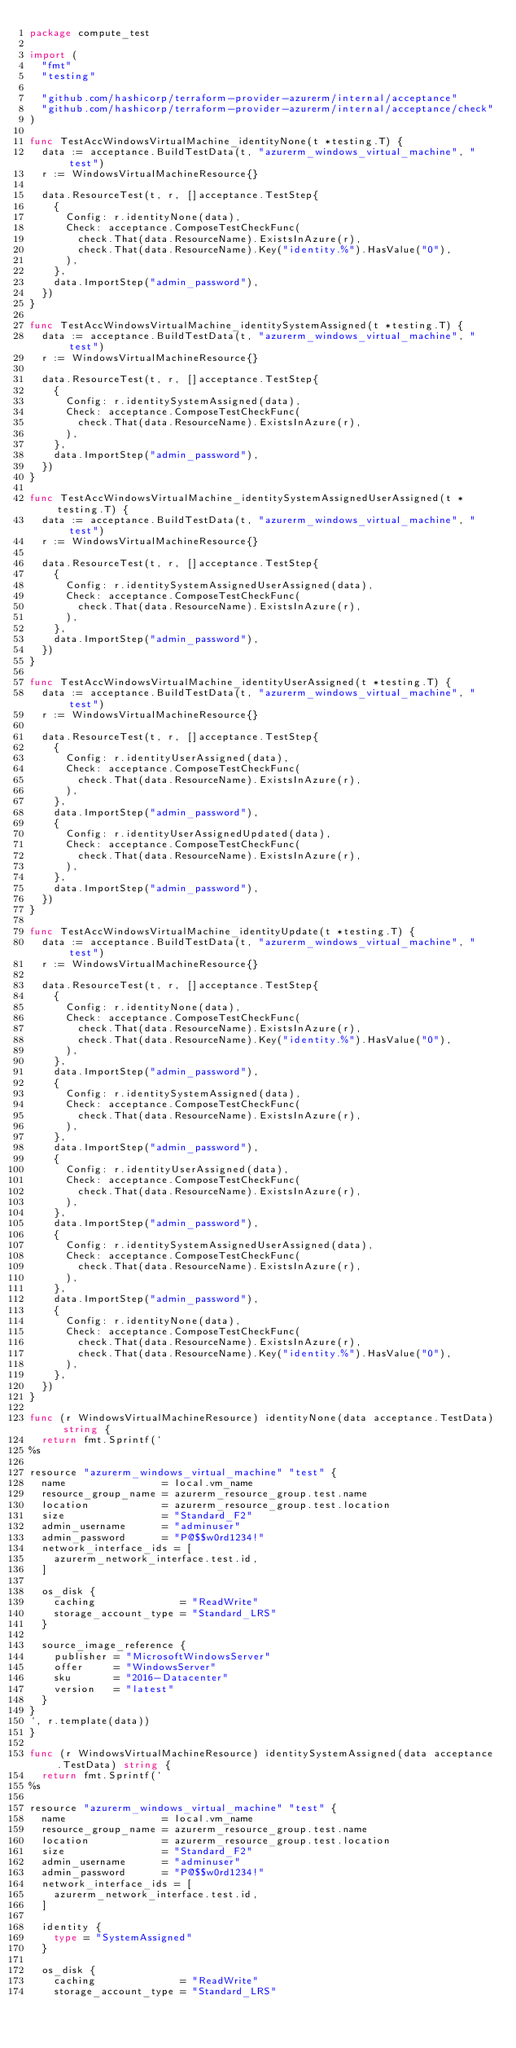Convert code to text. <code><loc_0><loc_0><loc_500><loc_500><_Go_>package compute_test

import (
	"fmt"
	"testing"

	"github.com/hashicorp/terraform-provider-azurerm/internal/acceptance"
	"github.com/hashicorp/terraform-provider-azurerm/internal/acceptance/check"
)

func TestAccWindowsVirtualMachine_identityNone(t *testing.T) {
	data := acceptance.BuildTestData(t, "azurerm_windows_virtual_machine", "test")
	r := WindowsVirtualMachineResource{}

	data.ResourceTest(t, r, []acceptance.TestStep{
		{
			Config: r.identityNone(data),
			Check: acceptance.ComposeTestCheckFunc(
				check.That(data.ResourceName).ExistsInAzure(r),
				check.That(data.ResourceName).Key("identity.%").HasValue("0"),
			),
		},
		data.ImportStep("admin_password"),
	})
}

func TestAccWindowsVirtualMachine_identitySystemAssigned(t *testing.T) {
	data := acceptance.BuildTestData(t, "azurerm_windows_virtual_machine", "test")
	r := WindowsVirtualMachineResource{}

	data.ResourceTest(t, r, []acceptance.TestStep{
		{
			Config: r.identitySystemAssigned(data),
			Check: acceptance.ComposeTestCheckFunc(
				check.That(data.ResourceName).ExistsInAzure(r),
			),
		},
		data.ImportStep("admin_password"),
	})
}

func TestAccWindowsVirtualMachine_identitySystemAssignedUserAssigned(t *testing.T) {
	data := acceptance.BuildTestData(t, "azurerm_windows_virtual_machine", "test")
	r := WindowsVirtualMachineResource{}

	data.ResourceTest(t, r, []acceptance.TestStep{
		{
			Config: r.identitySystemAssignedUserAssigned(data),
			Check: acceptance.ComposeTestCheckFunc(
				check.That(data.ResourceName).ExistsInAzure(r),
			),
		},
		data.ImportStep("admin_password"),
	})
}

func TestAccWindowsVirtualMachine_identityUserAssigned(t *testing.T) {
	data := acceptance.BuildTestData(t, "azurerm_windows_virtual_machine", "test")
	r := WindowsVirtualMachineResource{}

	data.ResourceTest(t, r, []acceptance.TestStep{
		{
			Config: r.identityUserAssigned(data),
			Check: acceptance.ComposeTestCheckFunc(
				check.That(data.ResourceName).ExistsInAzure(r),
			),
		},
		data.ImportStep("admin_password"),
		{
			Config: r.identityUserAssignedUpdated(data),
			Check: acceptance.ComposeTestCheckFunc(
				check.That(data.ResourceName).ExistsInAzure(r),
			),
		},
		data.ImportStep("admin_password"),
	})
}

func TestAccWindowsVirtualMachine_identityUpdate(t *testing.T) {
	data := acceptance.BuildTestData(t, "azurerm_windows_virtual_machine", "test")
	r := WindowsVirtualMachineResource{}

	data.ResourceTest(t, r, []acceptance.TestStep{
		{
			Config: r.identityNone(data),
			Check: acceptance.ComposeTestCheckFunc(
				check.That(data.ResourceName).ExistsInAzure(r),
				check.That(data.ResourceName).Key("identity.%").HasValue("0"),
			),
		},
		data.ImportStep("admin_password"),
		{
			Config: r.identitySystemAssigned(data),
			Check: acceptance.ComposeTestCheckFunc(
				check.That(data.ResourceName).ExistsInAzure(r),
			),
		},
		data.ImportStep("admin_password"),
		{
			Config: r.identityUserAssigned(data),
			Check: acceptance.ComposeTestCheckFunc(
				check.That(data.ResourceName).ExistsInAzure(r),
			),
		},
		data.ImportStep("admin_password"),
		{
			Config: r.identitySystemAssignedUserAssigned(data),
			Check: acceptance.ComposeTestCheckFunc(
				check.That(data.ResourceName).ExistsInAzure(r),
			),
		},
		data.ImportStep("admin_password"),
		{
			Config: r.identityNone(data),
			Check: acceptance.ComposeTestCheckFunc(
				check.That(data.ResourceName).ExistsInAzure(r),
				check.That(data.ResourceName).Key("identity.%").HasValue("0"),
			),
		},
	})
}

func (r WindowsVirtualMachineResource) identityNone(data acceptance.TestData) string {
	return fmt.Sprintf(`
%s

resource "azurerm_windows_virtual_machine" "test" {
  name                = local.vm_name
  resource_group_name = azurerm_resource_group.test.name
  location            = azurerm_resource_group.test.location
  size                = "Standard_F2"
  admin_username      = "adminuser"
  admin_password      = "P@$$w0rd1234!"
  network_interface_ids = [
    azurerm_network_interface.test.id,
  ]

  os_disk {
    caching              = "ReadWrite"
    storage_account_type = "Standard_LRS"
  }

  source_image_reference {
    publisher = "MicrosoftWindowsServer"
    offer     = "WindowsServer"
    sku       = "2016-Datacenter"
    version   = "latest"
  }
}
`, r.template(data))
}

func (r WindowsVirtualMachineResource) identitySystemAssigned(data acceptance.TestData) string {
	return fmt.Sprintf(`
%s

resource "azurerm_windows_virtual_machine" "test" {
  name                = local.vm_name
  resource_group_name = azurerm_resource_group.test.name
  location            = azurerm_resource_group.test.location
  size                = "Standard_F2"
  admin_username      = "adminuser"
  admin_password      = "P@$$w0rd1234!"
  network_interface_ids = [
    azurerm_network_interface.test.id,
  ]

  identity {
    type = "SystemAssigned"
  }

  os_disk {
    caching              = "ReadWrite"
    storage_account_type = "Standard_LRS"</code> 